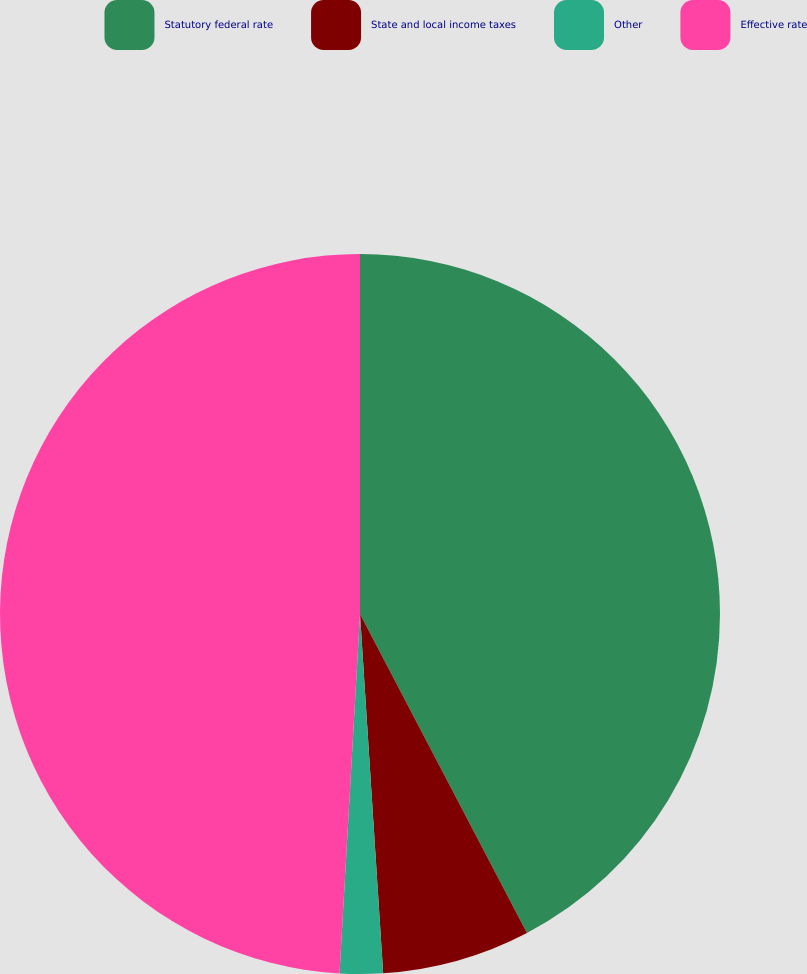<chart> <loc_0><loc_0><loc_500><loc_500><pie_chart><fcel>Statutory federal rate<fcel>State and local income taxes<fcel>Other<fcel>Effective rate<nl><fcel>42.32%<fcel>6.65%<fcel>1.93%<fcel>49.09%<nl></chart> 